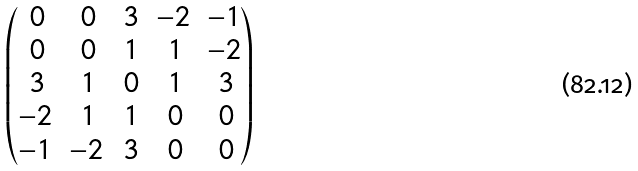Convert formula to latex. <formula><loc_0><loc_0><loc_500><loc_500>\begin{pmatrix} \, 0 & \, 0 & \, 3 & - 2 & - 1 \\ \, 0 & \, 0 & \, 1 & \, 1 & - 2 \\ \, 3 & \, 1 & \, 0 & \, 1 & \, 3 \\ - 2 & \, 1 & \, 1 & \, 0 & \, 0 \\ - 1 & - 2 & \, 3 & \, 0 & \, 0 \end{pmatrix}</formula> 